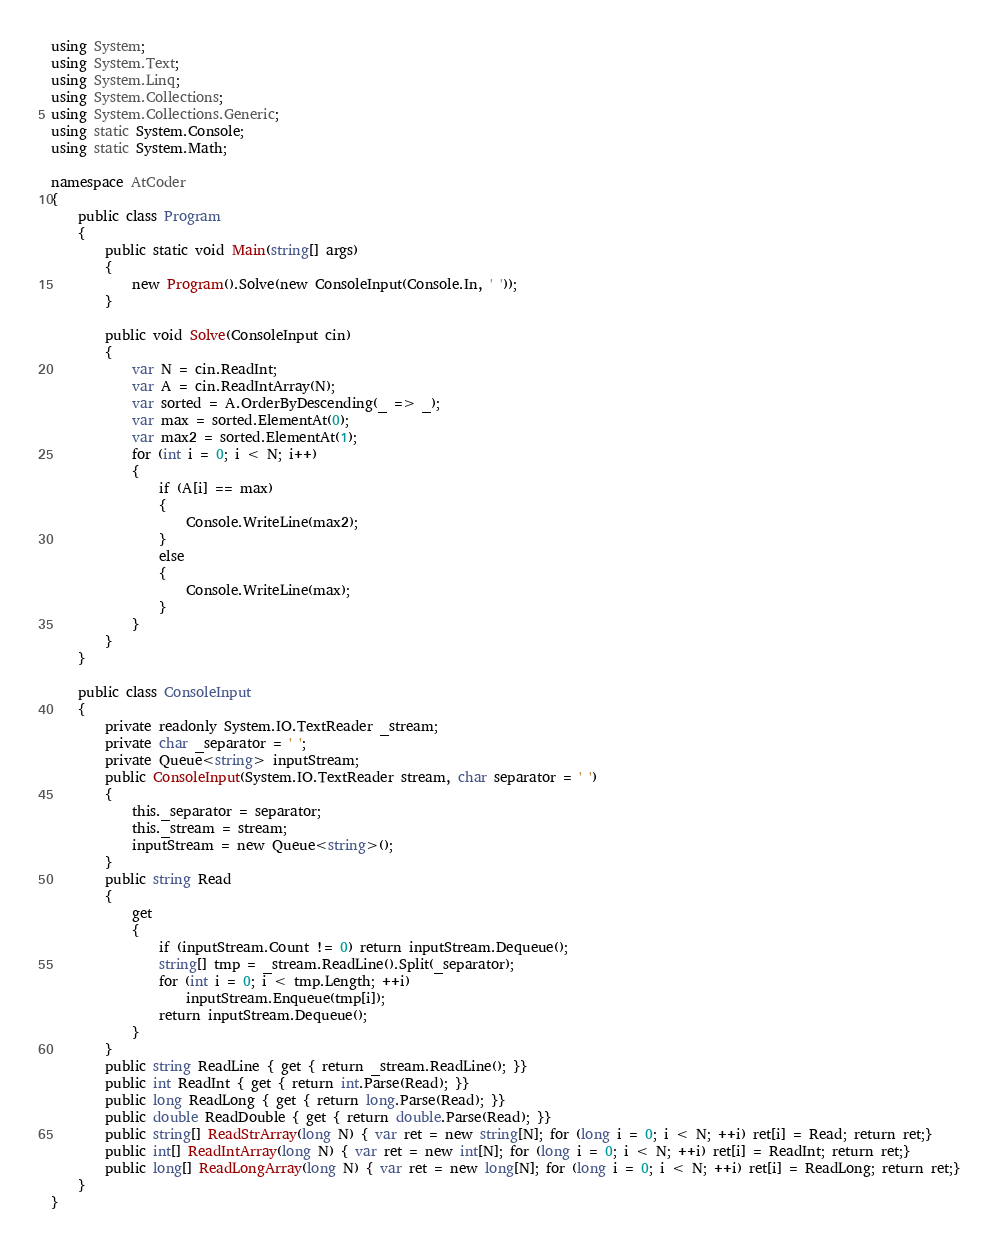Convert code to text. <code><loc_0><loc_0><loc_500><loc_500><_C#_>using System;
using System.Text;
using System.Linq;
using System.Collections;
using System.Collections.Generic;
using static System.Console;
using static System.Math;

namespace AtCoder
{
    public class Program
    {
        public static void Main(string[] args)
        {
            new Program().Solve(new ConsoleInput(Console.In, ' '));
        }

        public void Solve(ConsoleInput cin)
        {
            var N = cin.ReadInt;
            var A = cin.ReadIntArray(N);
            var sorted = A.OrderByDescending(_ => _);
            var max = sorted.ElementAt(0);
            var max2 = sorted.ElementAt(1);
            for (int i = 0; i < N; i++)
            {
                if (A[i] == max)
                {
                    Console.WriteLine(max2);
                }
                else
                {
                    Console.WriteLine(max);
                }
            }
        }
    }

    public class ConsoleInput
    {
        private readonly System.IO.TextReader _stream;
        private char _separator = ' ';
        private Queue<string> inputStream;
        public ConsoleInput(System.IO.TextReader stream, char separator = ' ')
        {
            this._separator = separator;
            this._stream = stream;
            inputStream = new Queue<string>();
        }
        public string Read
        {
            get
            {
                if (inputStream.Count != 0) return inputStream.Dequeue();
                string[] tmp = _stream.ReadLine().Split(_separator);
                for (int i = 0; i < tmp.Length; ++i)
                    inputStream.Enqueue(tmp[i]);
                return inputStream.Dequeue();
            }
        }
        public string ReadLine { get { return _stream.ReadLine(); }}
        public int ReadInt { get { return int.Parse(Read); }}
        public long ReadLong { get { return long.Parse(Read); }}
        public double ReadDouble { get { return double.Parse(Read); }}
        public string[] ReadStrArray(long N) { var ret = new string[N]; for (long i = 0; i < N; ++i) ret[i] = Read; return ret;}
        public int[] ReadIntArray(long N) { var ret = new int[N]; for (long i = 0; i < N; ++i) ret[i] = ReadInt; return ret;}
        public long[] ReadLongArray(long N) { var ret = new long[N]; for (long i = 0; i < N; ++i) ret[i] = ReadLong; return ret;}
    }
}
</code> 